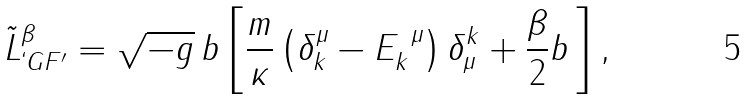Convert formula to latex. <formula><loc_0><loc_0><loc_500><loc_500>\tilde { L } ^ { \beta } _ { ` G F ^ { \prime } } = \sqrt { - g } \, b \left [ \frac { m } { \kappa } \left ( \delta ^ { \mu } _ { k } - E _ { k } ^ { \ \mu } \right ) \delta ^ { k } _ { \mu } + \frac { \beta } { 2 } b \, \right ] ,</formula> 